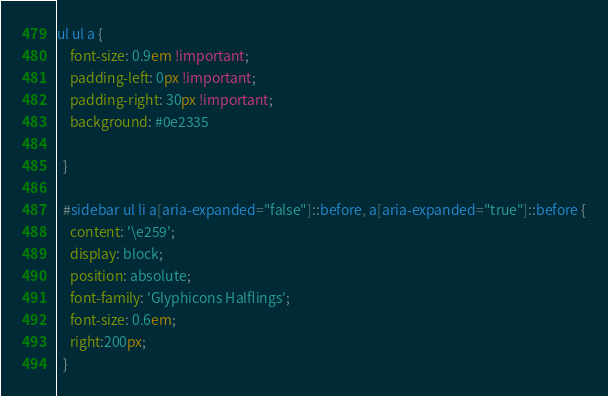<code> <loc_0><loc_0><loc_500><loc_500><_CSS_>ul ul a {
    font-size: 0.9em !important;
    padding-left: 0px !important;
    padding-right: 30px !important;
    background: #0e2335
  
  }

  #sidebar ul li a[aria-expanded="false"]::before, a[aria-expanded="true"]::before {
    content: '\e259';
    display: block;
    position: absolute;
    font-family: 'Glyphicons Halflings';
    font-size: 0.6em;
    right:200px;
  }</code> 